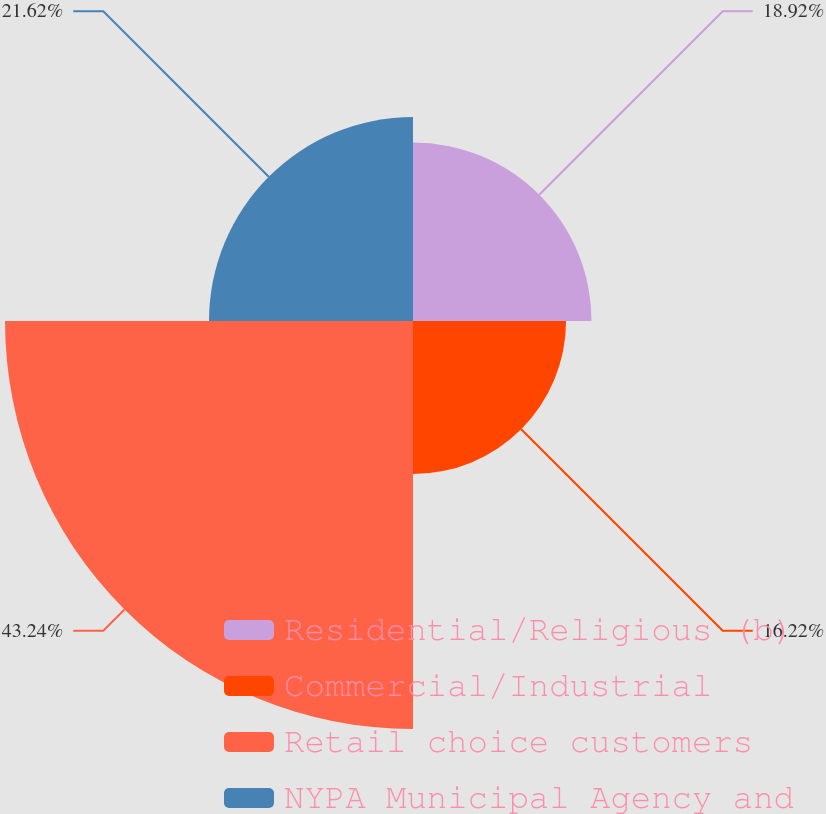Convert chart to OTSL. <chart><loc_0><loc_0><loc_500><loc_500><pie_chart><fcel>Residential/Religious (b)<fcel>Commercial/Industrial<fcel>Retail choice customers<fcel>NYPA Municipal Agency and<nl><fcel>18.92%<fcel>16.22%<fcel>43.24%<fcel>21.62%<nl></chart> 